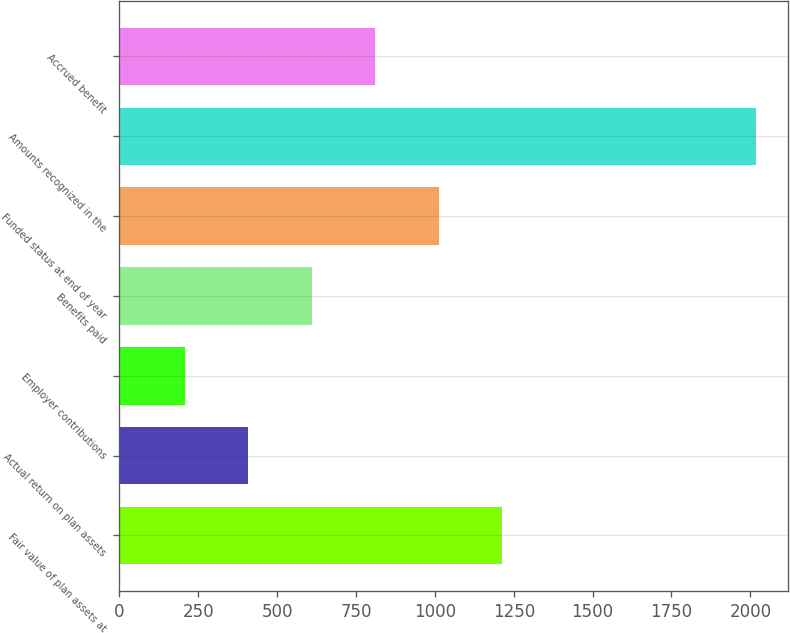Convert chart. <chart><loc_0><loc_0><loc_500><loc_500><bar_chart><fcel>Fair value of plan assets at<fcel>Actual return on plan assets<fcel>Employer contributions<fcel>Benefits paid<fcel>Funded status at end of year<fcel>Amounts recognized in the<fcel>Accrued benefit<nl><fcel>1212.8<fcel>407.6<fcel>206.3<fcel>608.9<fcel>1011.5<fcel>2018<fcel>810.2<nl></chart> 